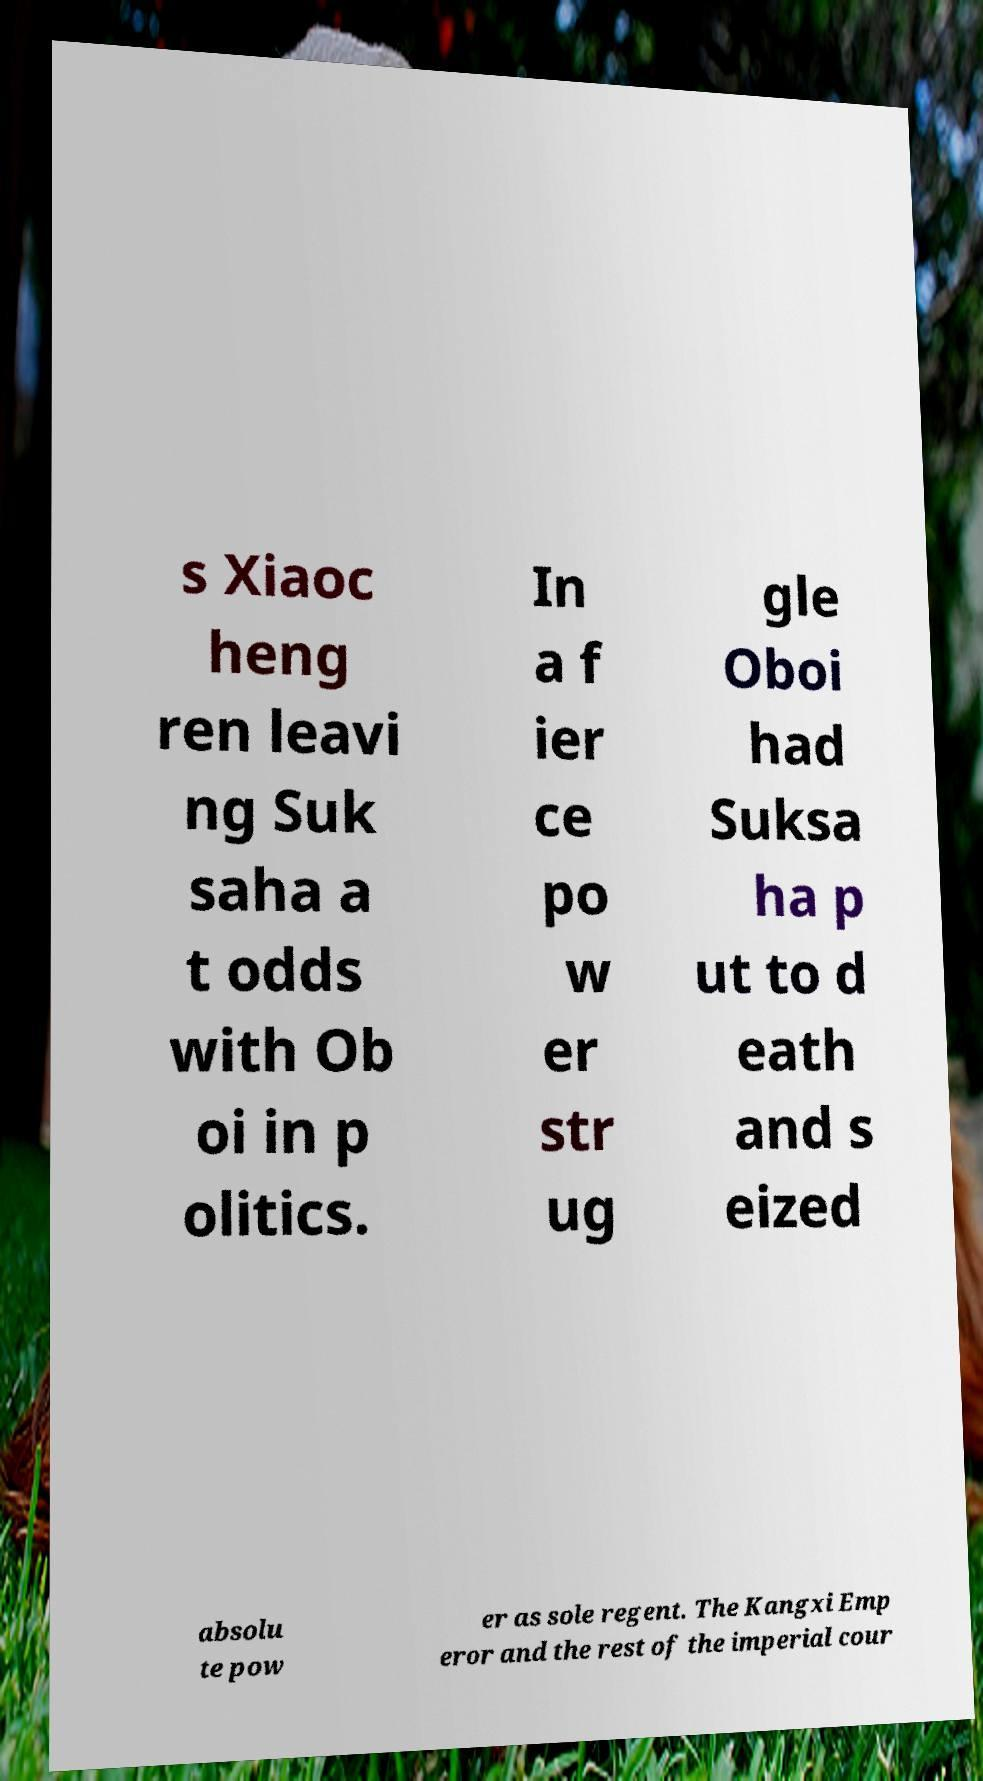Please read and relay the text visible in this image. What does it say? s Xiaoc heng ren leavi ng Suk saha a t odds with Ob oi in p olitics. In a f ier ce po w er str ug gle Oboi had Suksa ha p ut to d eath and s eized absolu te pow er as sole regent. The Kangxi Emp eror and the rest of the imperial cour 